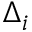Convert formula to latex. <formula><loc_0><loc_0><loc_500><loc_500>\Delta _ { i }</formula> 